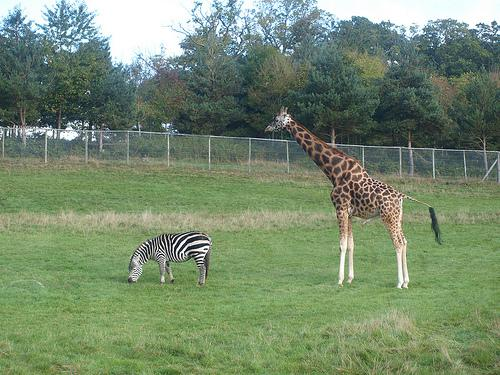Explain the visual characteristics of both animals and the environment they are in. The zebra has black and white stripes and is grazing on grass, while the giraffe has brown spots, a long neck, and is standing on grass in the enclosure. Describe the interaction between the two main subjects in the image. The giraffe appears happy to see the zebra, which is standing in front of it and grazing on grass in the enclosure. Provide a short description of the scene with the focus on the main subjects and their surroundings. A zebra and giraffe are in a field enclosed by a chain link fence, with trees and green grass around them at the zoo. Provide a summary of the image, mentioning the main features and setting of the scene. The image shows a zebra and giraffe in an enclosure with a chain link fence, trees, and green grass, with both animals engaged in different activities. Write a brief sentence about the two animals and where they are situated. A zebra and giraffe are together in a fenced enclosure at the zoo, surrounded by trees and grass. Briefly list the main objects and their location in the image. Zebra grazing on grass, giraffe happily standing, chain link fence, trees, and green grass field in a zoo enclosure. Briefly explain what the zebra and giraffe are doing and where they are located. The zebra is eating grass while standing in front of the giraffe, both located in a fenced field at the zoo. Identify the two primary animals and their actions in the image. A zebra is grazing on grass with its head down, and a happy giraffe is standing nearby with its long neck up high. Mention the setting where the animals are placed and describe the environment behind them. The zebra and giraffe are in a small enclosure with a chain link fence, surrounded by trees in the background and green grass in the pasture. Mention the primary subjects in the image and describe the overall environment they are in. A zebra is eating grass and a giraffe is standing nearby, both situated in a fenced field with trees and green grass at the zoo. 